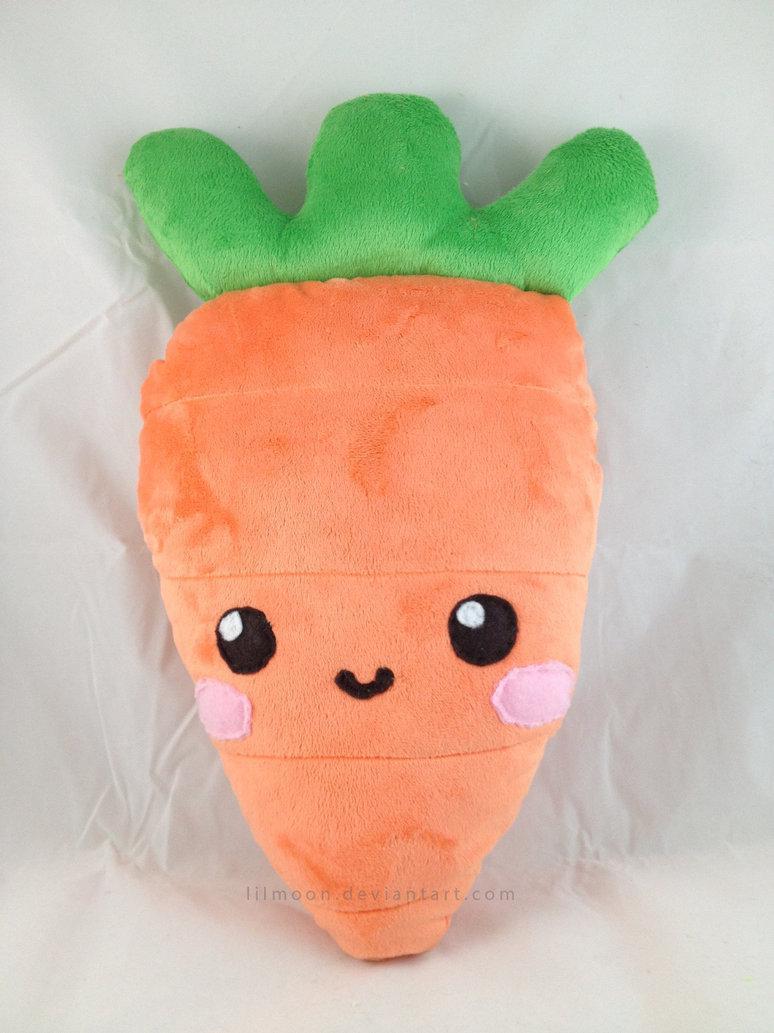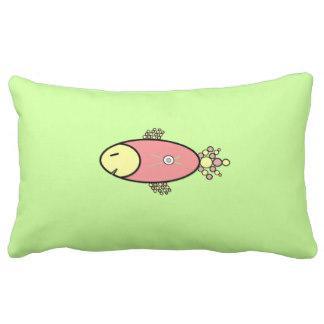The first image is the image on the left, the second image is the image on the right. Analyze the images presented: Is the assertion "An image shows a four-sided pillow shape with at least one animal image on it." valid? Answer yes or no. Yes. The first image is the image on the left, the second image is the image on the right. Given the left and right images, does the statement "The right image is a stack of at least 7 multicolored pillows, while the left image is a single square shaped pillow." hold true? Answer yes or no. No. 